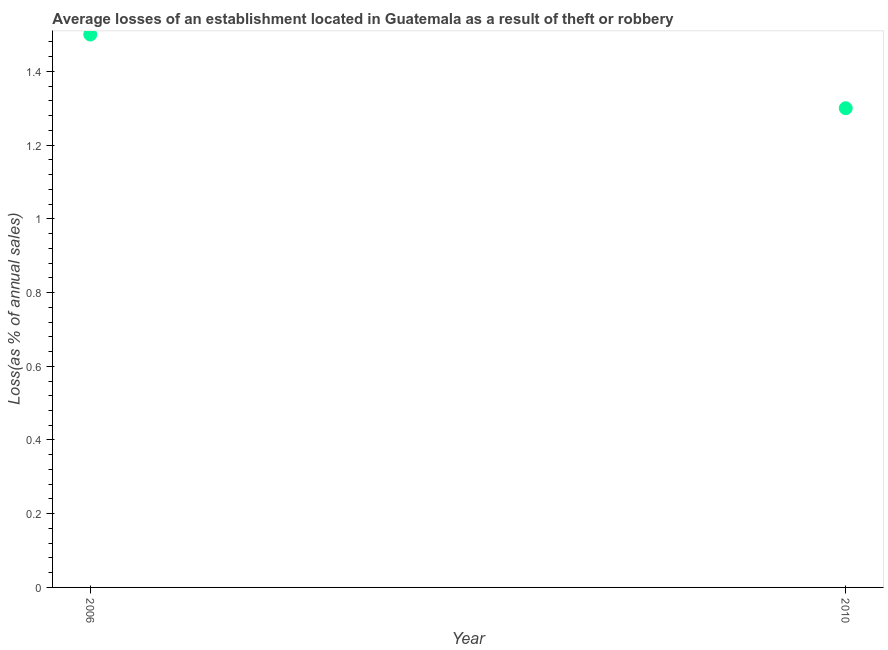What is the losses due to theft in 2010?
Your response must be concise. 1.3. Across all years, what is the maximum losses due to theft?
Give a very brief answer. 1.5. What is the difference between the losses due to theft in 2006 and 2010?
Give a very brief answer. 0.2. What is the median losses due to theft?
Keep it short and to the point. 1.4. In how many years, is the losses due to theft greater than 1 %?
Your answer should be compact. 2. What is the ratio of the losses due to theft in 2006 to that in 2010?
Ensure brevity in your answer.  1.15. Is the losses due to theft in 2006 less than that in 2010?
Offer a very short reply. No. How many dotlines are there?
Provide a succinct answer. 1. How many years are there in the graph?
Your response must be concise. 2. Are the values on the major ticks of Y-axis written in scientific E-notation?
Your answer should be compact. No. Does the graph contain grids?
Keep it short and to the point. No. What is the title of the graph?
Your response must be concise. Average losses of an establishment located in Guatemala as a result of theft or robbery. What is the label or title of the Y-axis?
Keep it short and to the point. Loss(as % of annual sales). What is the Loss(as % of annual sales) in 2010?
Ensure brevity in your answer.  1.3. What is the ratio of the Loss(as % of annual sales) in 2006 to that in 2010?
Your response must be concise. 1.15. 